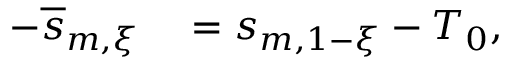Convert formula to latex. <formula><loc_0><loc_0><loc_500><loc_500>\begin{array} { r l } { - \overline { s } _ { m , \xi } } & = s _ { m , 1 - \xi } - T _ { 0 } , } \end{array}</formula> 